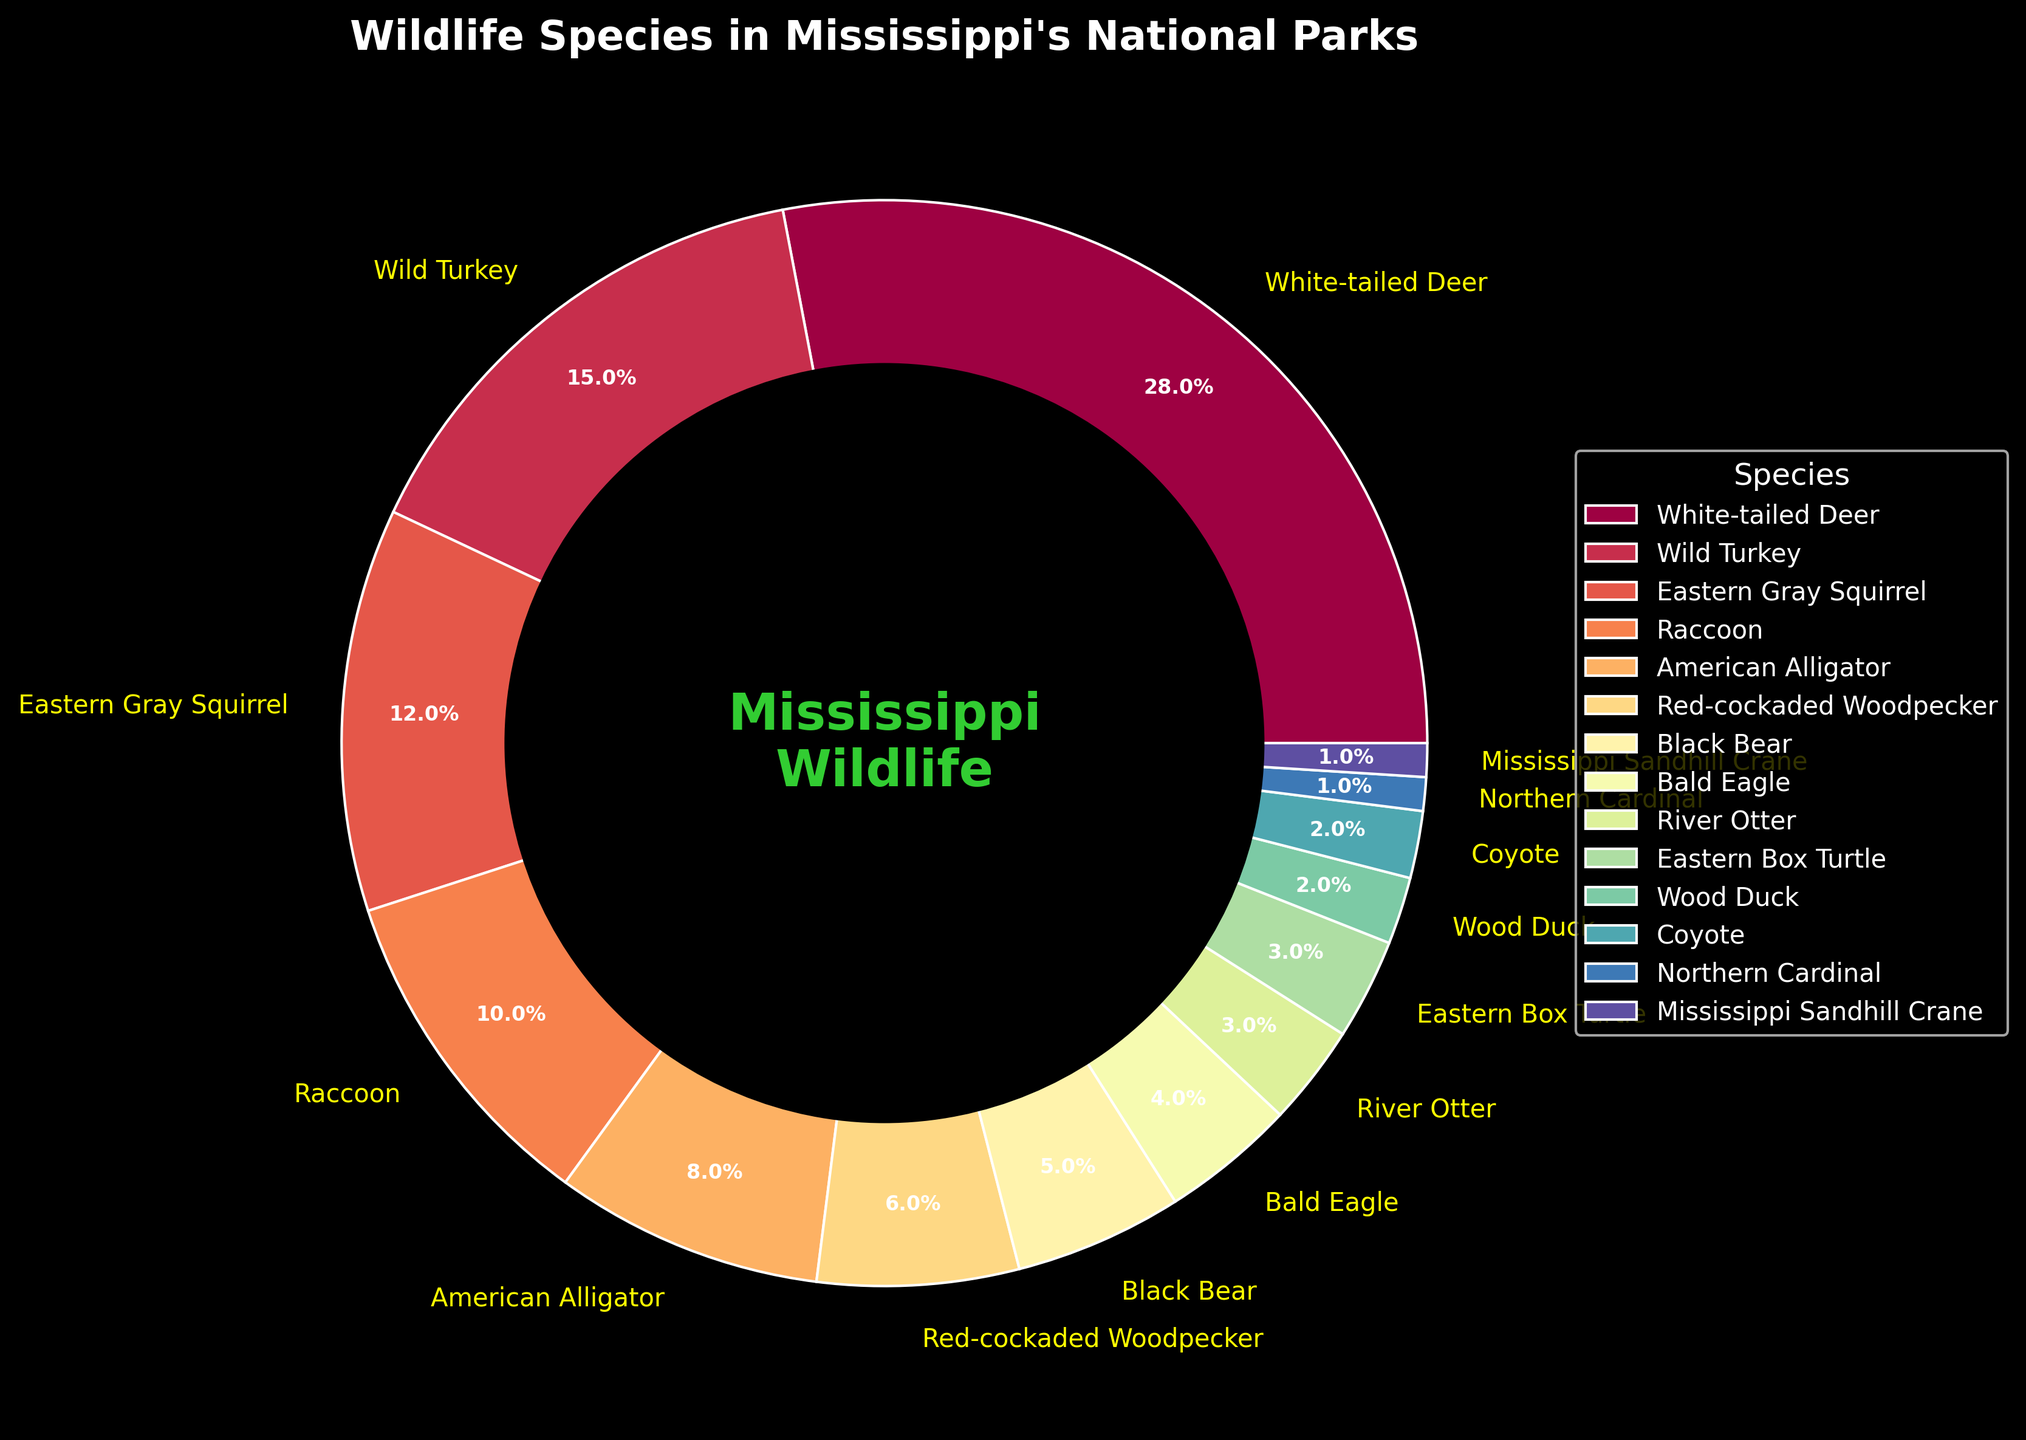Which species has the highest percentage of wildlife in Mississippi's national parks? By looking at the pie chart, we can identify the species with the largest wedge. The percentage label indicates this species.
Answer: White-tailed Deer What are the combined percentages of the White-tailed Deer and Eastern Gray Squirrel? The White-tailed Deer has a percentage of 28 and the Eastern Gray Squirrel has 12. Adding these percentages gives 28 + 12.
Answer: 40% Which species has a lower percentage, American Alligator or Red-cockaded Woodpecker? By comparing the percentage labels on the pie chart, we note the American Alligator has 8% while the Red-cockaded Woodpecker has 6%. Thus, Red-cockaded Woodpecker has the lower percentage.
Answer: Red-cockaded Woodpecker Is the percentage of the Wild Turkey higher than double the percentage of the Bald Eagle? The Wild Turkey has a percentage of 15, while the Bald Eagle has 4. Double the Bald Eagle's percentage is 8 (2*4). Since 15 is greater than 8, the answer is yes.
Answer: Yes Which species has a brighter or more vibrant color on the chart, the Eastern Gray Squirrel or the River Otter? Referring to the Spectral color palette used in the pie chart, the Eastern Gray Squirrel is likely to have a brighter color as the palette progresses from light to dark across the species.
Answer: Eastern Gray Squirrel What is the total percentage of species that are less than 5% on the chart? Add the percentages of the species with less than 5%. Bald Eagle (4), River Otter (3), Eastern Box Turtle (3), Wood Duck (2), Coyote (2), Northern Cardinal (1), and Mississippi Sandhill Crane (1). Summing them up: 4 + 3 + 3 + 2 + 2 + 1 + 1 = 16.
Answer: 16% Between the Black Bear and the American Alligator, which species occupies a larger segment of the chart? The Black Bear has a percentage of 5, while the American Alligator has 8. By comparing these labels, the American Alligator occupies a larger segment.
Answer: American Alligator What is the percentage difference between the White-tailed Deer and the Wild Turkey? The White-tailed Deer has a percentage of 28 and the Wild Turkey has 15. Subtracting these gives 28 - 15.
Answer: 13% What is the smallest percentage shown in the chart and to which species does it belong? Look at the smallest percentage label on the pie chart. The smallest percentage shown is 1%, belonging to both the Northern Cardinal and Mississippi Sandhill Crane.
Answer: 1%, Northern Cardinal, Mississippi Sandhill Crane 